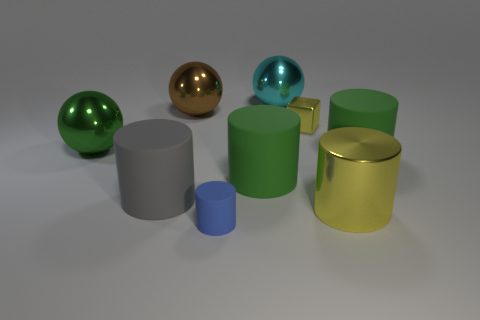Subtract all gray cylinders. How many cylinders are left? 4 Subtract all blue rubber cylinders. How many cylinders are left? 4 Subtract all cyan cylinders. Subtract all brown spheres. How many cylinders are left? 5 Add 1 large gray rubber cylinders. How many objects exist? 10 Subtract all spheres. How many objects are left? 6 Add 2 large green spheres. How many large green spheres are left? 3 Add 2 large cyan rubber objects. How many large cyan rubber objects exist? 2 Subtract 0 purple cylinders. How many objects are left? 9 Subtract all tiny blue matte objects. Subtract all tiny brown cylinders. How many objects are left? 8 